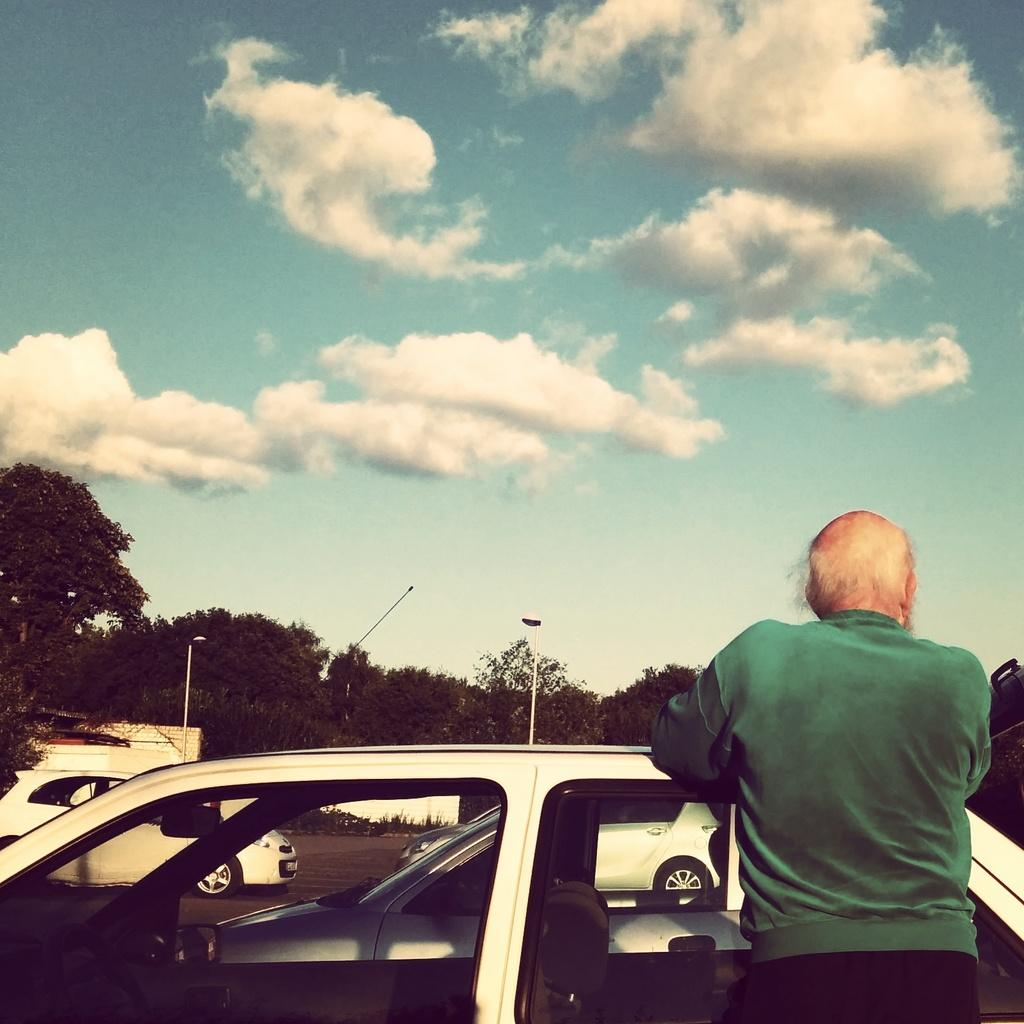What is located at the bottom of the image? There is a car and a person standing at the bottom of the image. What can be seen in the background of the image? There are cars, trees, poles, and lights in the background of the image. What is visible at the top of the image? The sky is visible at the top of the image. What type of organization is depicted in the image? There is no organization depicted in the image; it features a car, a person, and various background elements. Can you tell me how many achievers are present in the image? There is no mention of achievers in the image; it simply shows a car, a person, and various background elements. 